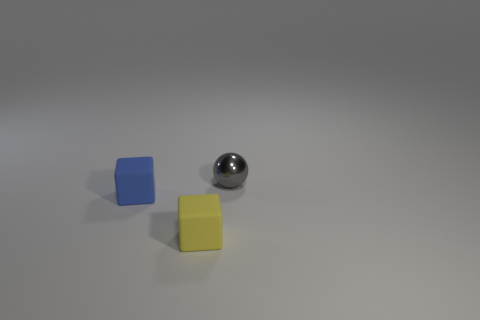What is the color of the other rubber object that is the same shape as the tiny yellow matte object?
Provide a succinct answer. Blue. Is the number of blue things on the right side of the gray shiny object less than the number of tiny rubber cubes that are on the left side of the small yellow cube?
Your response must be concise. Yes. What is the color of the block that is on the left side of the tiny yellow rubber cube?
Your answer should be compact. Blue. There is a object that is in front of the blue block; is it the same size as the blue block?
Your answer should be very brief. Yes. What number of blue blocks are behind the tiny shiny ball?
Your answer should be compact. 0. Is there a yellow rubber thing of the same size as the yellow cube?
Keep it short and to the point. No. There is a small block that is in front of the matte cube left of the tiny yellow rubber block; what color is it?
Keep it short and to the point. Yellow. What number of rubber blocks are to the right of the blue block and behind the yellow cube?
Keep it short and to the point. 0. How many small blue matte things have the same shape as the yellow object?
Offer a terse response. 1. Is the small ball made of the same material as the yellow thing?
Offer a very short reply. No. 